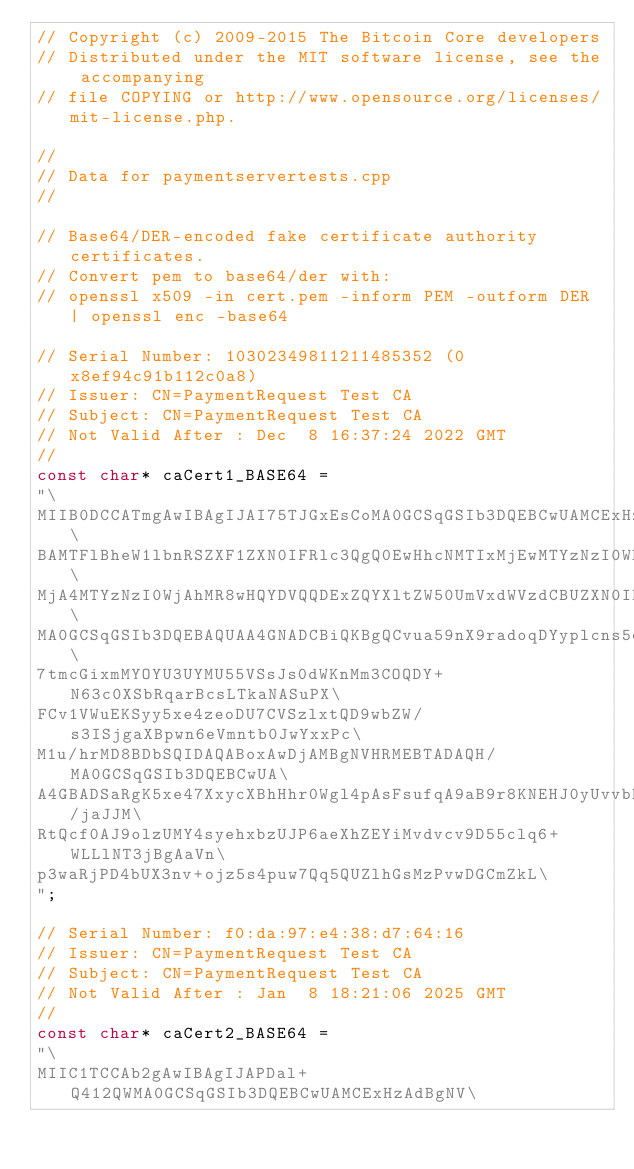Convert code to text. <code><loc_0><loc_0><loc_500><loc_500><_C_>// Copyright (c) 2009-2015 The Bitcoin Core developers
// Distributed under the MIT software license, see the accompanying
// file COPYING or http://www.opensource.org/licenses/mit-license.php.

//
// Data for paymentservertests.cpp
//

// Base64/DER-encoded fake certificate authority certificates.
// Convert pem to base64/der with:
// openssl x509 -in cert.pem -inform PEM -outform DER | openssl enc -base64

// Serial Number: 10302349811211485352 (0x8ef94c91b112c0a8)
// Issuer: CN=PaymentRequest Test CA
// Subject: CN=PaymentRequest Test CA
// Not Valid After : Dec  8 16:37:24 2022 GMT
//
const char* caCert1_BASE64 =
"\
MIIB0DCCATmgAwIBAgIJAI75TJGxEsCoMA0GCSqGSIb3DQEBCwUAMCExHzAdBgNV\
BAMTFlBheW1lbnRSZXF1ZXN0IFRlc3QgQ0EwHhcNMTIxMjEwMTYzNzI0WhcNMjIx\
MjA4MTYzNzI0WjAhMR8wHQYDVQQDExZQYXltZW50UmVxdWVzdCBUZXN0IENBMIGf\
MA0GCSqGSIb3DQEBAQUAA4GNADCBiQKBgQCvua59nX9radoqDYyplcns5qdVDTN1\
7tmcGixmMYOYU3UYMU55VSsJs0dWKnMm3COQDY+N63c0XSbRqarBcsLTkaNASuPX\
FCv1VWuEKSyy5xe4zeoDU7CVSzlxtQD9wbZW/s3ISjgaXBpwn6eVmntb0JwYxxPc\
M1u/hrMD8BDbSQIDAQABoxAwDjAMBgNVHRMEBTADAQH/MA0GCSqGSIb3DQEBCwUA\
A4GBADSaRgK5xe47XxycXBhHhr0Wgl4pAsFsufqA9aB9r8KNEHJ0yUvvbD/jaJJM\
RtQcf0AJ9olzUMY4syehxbzUJP6aeXhZEYiMvdvcv9D55clq6+WLLlNT3jBgAaVn\
p3waRjPD4bUX3nv+ojz5s4puw7Qq5QUZlhGsMzPvwDGCmZkL\
";

// Serial Number: f0:da:97:e4:38:d7:64:16
// Issuer: CN=PaymentRequest Test CA
// Subject: CN=PaymentRequest Test CA
// Not Valid After : Jan  8 18:21:06 2025 GMT
//
const char* caCert2_BASE64 =
"\
MIIC1TCCAb2gAwIBAgIJAPDal+Q412QWMA0GCSqGSIb3DQEBCwUAMCExHzAdBgNV\</code> 